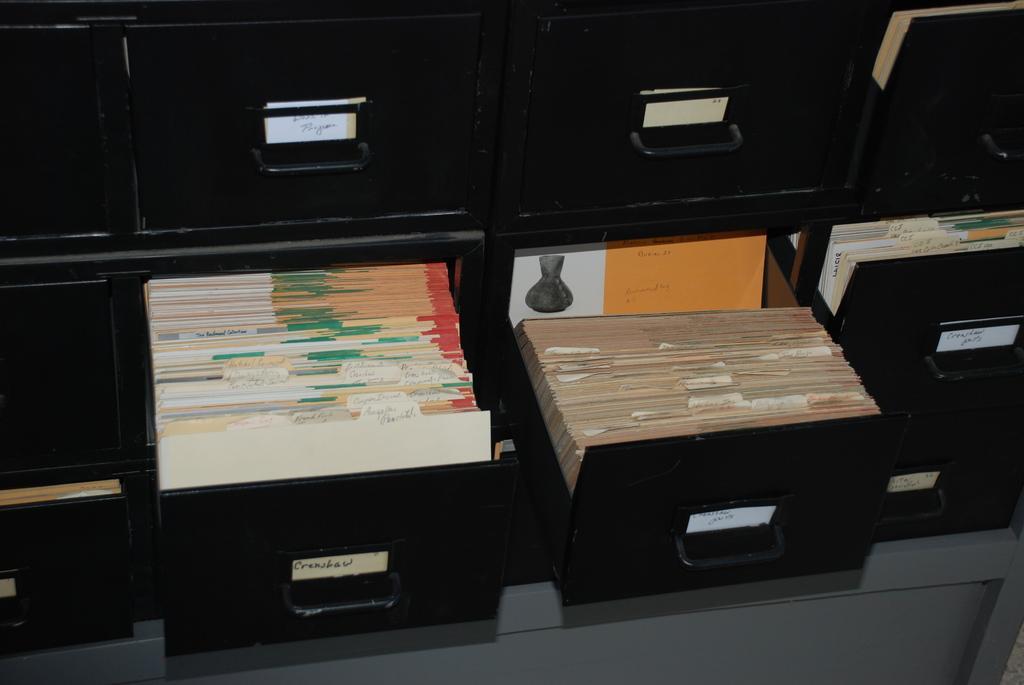Describe this image in one or two sentences. In this image in the front there are drawers which are black in colour and in the drawer there are objects which are white and brown in colour. 